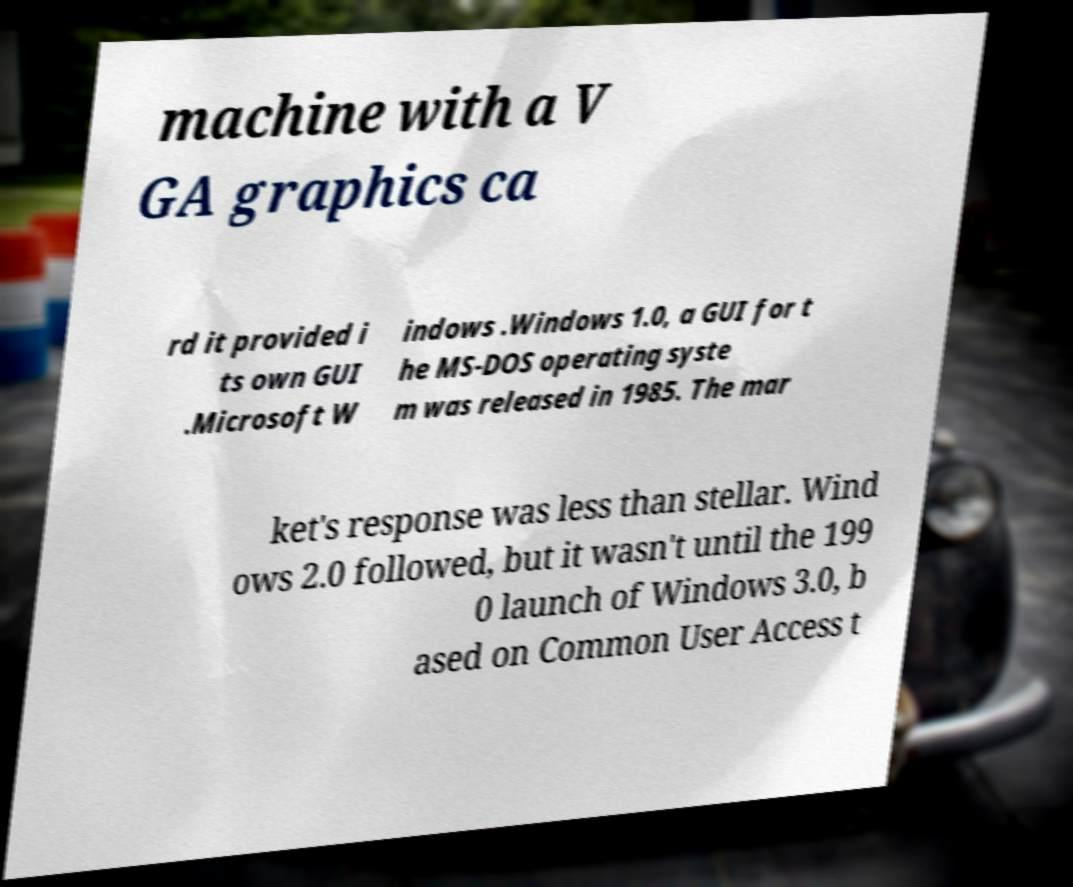What messages or text are displayed in this image? I need them in a readable, typed format. machine with a V GA graphics ca rd it provided i ts own GUI .Microsoft W indows .Windows 1.0, a GUI for t he MS-DOS operating syste m was released in 1985. The mar ket's response was less than stellar. Wind ows 2.0 followed, but it wasn't until the 199 0 launch of Windows 3.0, b ased on Common User Access t 